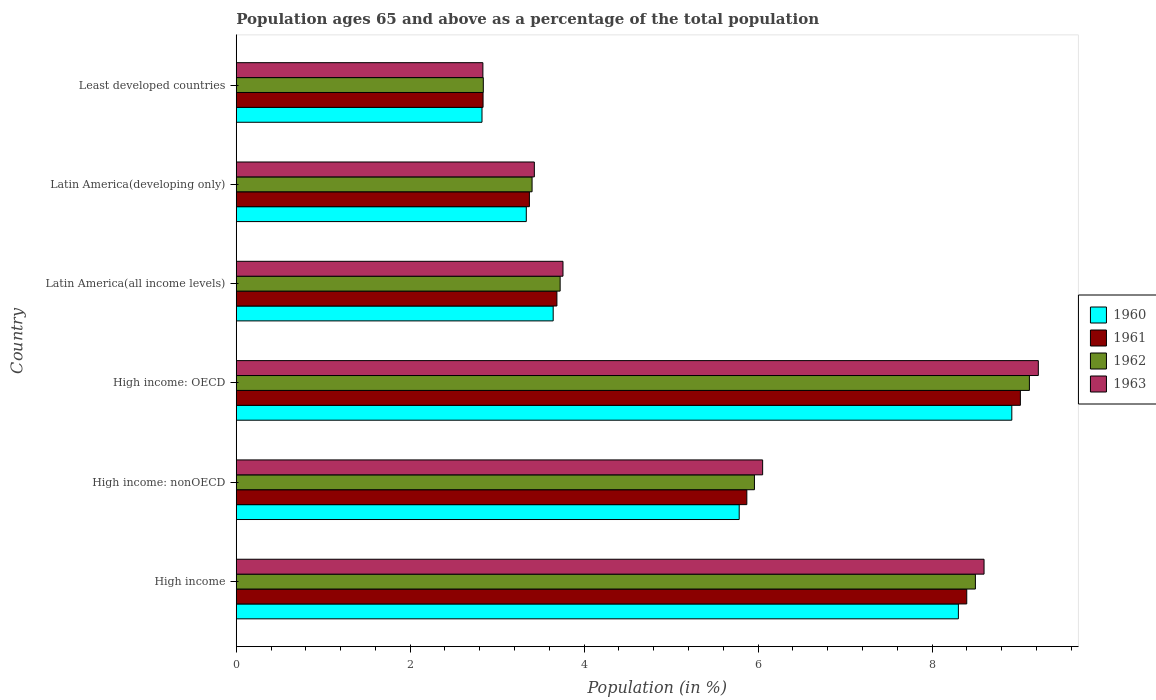How many groups of bars are there?
Provide a short and direct response. 6. Are the number of bars per tick equal to the number of legend labels?
Your answer should be very brief. Yes. Are the number of bars on each tick of the Y-axis equal?
Give a very brief answer. Yes. What is the label of the 1st group of bars from the top?
Keep it short and to the point. Least developed countries. What is the percentage of the population ages 65 and above in 1960 in Latin America(all income levels)?
Provide a succinct answer. 3.64. Across all countries, what is the maximum percentage of the population ages 65 and above in 1963?
Make the answer very short. 9.22. Across all countries, what is the minimum percentage of the population ages 65 and above in 1960?
Your answer should be very brief. 2.83. In which country was the percentage of the population ages 65 and above in 1960 maximum?
Your answer should be compact. High income: OECD. In which country was the percentage of the population ages 65 and above in 1963 minimum?
Give a very brief answer. Least developed countries. What is the total percentage of the population ages 65 and above in 1961 in the graph?
Your answer should be very brief. 33.18. What is the difference between the percentage of the population ages 65 and above in 1962 in High income and that in Least developed countries?
Provide a succinct answer. 5.66. What is the difference between the percentage of the population ages 65 and above in 1961 in Latin America(all income levels) and the percentage of the population ages 65 and above in 1960 in Latin America(developing only)?
Your answer should be very brief. 0.35. What is the average percentage of the population ages 65 and above in 1960 per country?
Give a very brief answer. 5.47. What is the difference between the percentage of the population ages 65 and above in 1963 and percentage of the population ages 65 and above in 1960 in High income?
Offer a terse response. 0.3. What is the ratio of the percentage of the population ages 65 and above in 1960 in High income: OECD to that in High income: nonOECD?
Your answer should be very brief. 1.54. Is the percentage of the population ages 65 and above in 1962 in High income less than that in Least developed countries?
Your response must be concise. No. What is the difference between the highest and the second highest percentage of the population ages 65 and above in 1963?
Your answer should be compact. 0.62. What is the difference between the highest and the lowest percentage of the population ages 65 and above in 1962?
Offer a very short reply. 6.28. In how many countries, is the percentage of the population ages 65 and above in 1963 greater than the average percentage of the population ages 65 and above in 1963 taken over all countries?
Offer a very short reply. 3. What does the 1st bar from the top in High income: nonOECD represents?
Keep it short and to the point. 1963. What does the 3rd bar from the bottom in High income: nonOECD represents?
Your answer should be very brief. 1962. How many bars are there?
Offer a terse response. 24. Are the values on the major ticks of X-axis written in scientific E-notation?
Offer a very short reply. No. Does the graph contain any zero values?
Keep it short and to the point. No. Does the graph contain grids?
Ensure brevity in your answer.  No. How many legend labels are there?
Give a very brief answer. 4. What is the title of the graph?
Provide a short and direct response. Population ages 65 and above as a percentage of the total population. What is the label or title of the Y-axis?
Make the answer very short. Country. What is the Population (in %) of 1960 in High income?
Make the answer very short. 8.3. What is the Population (in %) of 1961 in High income?
Ensure brevity in your answer.  8.4. What is the Population (in %) of 1962 in High income?
Provide a short and direct response. 8.5. What is the Population (in %) of 1963 in High income?
Your response must be concise. 8.6. What is the Population (in %) in 1960 in High income: nonOECD?
Your answer should be compact. 5.78. What is the Population (in %) of 1961 in High income: nonOECD?
Give a very brief answer. 5.87. What is the Population (in %) of 1962 in High income: nonOECD?
Offer a very short reply. 5.96. What is the Population (in %) of 1963 in High income: nonOECD?
Your answer should be compact. 6.05. What is the Population (in %) in 1960 in High income: OECD?
Your answer should be very brief. 8.92. What is the Population (in %) in 1961 in High income: OECD?
Your response must be concise. 9.02. What is the Population (in %) of 1962 in High income: OECD?
Ensure brevity in your answer.  9.12. What is the Population (in %) in 1963 in High income: OECD?
Provide a short and direct response. 9.22. What is the Population (in %) of 1960 in Latin America(all income levels)?
Provide a short and direct response. 3.64. What is the Population (in %) of 1961 in Latin America(all income levels)?
Your answer should be compact. 3.69. What is the Population (in %) of 1962 in Latin America(all income levels)?
Offer a very short reply. 3.72. What is the Population (in %) in 1963 in Latin America(all income levels)?
Provide a succinct answer. 3.76. What is the Population (in %) of 1960 in Latin America(developing only)?
Keep it short and to the point. 3.33. What is the Population (in %) in 1961 in Latin America(developing only)?
Provide a short and direct response. 3.37. What is the Population (in %) of 1962 in Latin America(developing only)?
Your answer should be very brief. 3.4. What is the Population (in %) in 1963 in Latin America(developing only)?
Ensure brevity in your answer.  3.43. What is the Population (in %) in 1960 in Least developed countries?
Your answer should be compact. 2.83. What is the Population (in %) in 1961 in Least developed countries?
Offer a very short reply. 2.84. What is the Population (in %) in 1962 in Least developed countries?
Ensure brevity in your answer.  2.84. What is the Population (in %) in 1963 in Least developed countries?
Your answer should be compact. 2.84. Across all countries, what is the maximum Population (in %) of 1960?
Ensure brevity in your answer.  8.92. Across all countries, what is the maximum Population (in %) in 1961?
Offer a very short reply. 9.02. Across all countries, what is the maximum Population (in %) of 1962?
Your answer should be very brief. 9.12. Across all countries, what is the maximum Population (in %) of 1963?
Your answer should be compact. 9.22. Across all countries, what is the minimum Population (in %) of 1960?
Give a very brief answer. 2.83. Across all countries, what is the minimum Population (in %) in 1961?
Ensure brevity in your answer.  2.84. Across all countries, what is the minimum Population (in %) in 1962?
Provide a succinct answer. 2.84. Across all countries, what is the minimum Population (in %) of 1963?
Ensure brevity in your answer.  2.84. What is the total Population (in %) in 1960 in the graph?
Your response must be concise. 32.81. What is the total Population (in %) of 1961 in the graph?
Ensure brevity in your answer.  33.18. What is the total Population (in %) in 1962 in the graph?
Ensure brevity in your answer.  33.54. What is the total Population (in %) of 1963 in the graph?
Provide a short and direct response. 33.89. What is the difference between the Population (in %) in 1960 in High income and that in High income: nonOECD?
Provide a short and direct response. 2.52. What is the difference between the Population (in %) in 1961 in High income and that in High income: nonOECD?
Give a very brief answer. 2.53. What is the difference between the Population (in %) in 1962 in High income and that in High income: nonOECD?
Ensure brevity in your answer.  2.54. What is the difference between the Population (in %) in 1963 in High income and that in High income: nonOECD?
Your answer should be compact. 2.55. What is the difference between the Population (in %) in 1960 in High income and that in High income: OECD?
Make the answer very short. -0.61. What is the difference between the Population (in %) in 1961 in High income and that in High income: OECD?
Offer a terse response. -0.62. What is the difference between the Population (in %) in 1962 in High income and that in High income: OECD?
Your answer should be very brief. -0.62. What is the difference between the Population (in %) in 1963 in High income and that in High income: OECD?
Offer a very short reply. -0.62. What is the difference between the Population (in %) in 1960 in High income and that in Latin America(all income levels)?
Provide a succinct answer. 4.66. What is the difference between the Population (in %) of 1961 in High income and that in Latin America(all income levels)?
Your answer should be very brief. 4.71. What is the difference between the Population (in %) of 1962 in High income and that in Latin America(all income levels)?
Your answer should be compact. 4.77. What is the difference between the Population (in %) of 1963 in High income and that in Latin America(all income levels)?
Your response must be concise. 4.84. What is the difference between the Population (in %) in 1960 in High income and that in Latin America(developing only)?
Your answer should be compact. 4.97. What is the difference between the Population (in %) in 1961 in High income and that in Latin America(developing only)?
Keep it short and to the point. 5.03. What is the difference between the Population (in %) of 1962 in High income and that in Latin America(developing only)?
Provide a succinct answer. 5.1. What is the difference between the Population (in %) in 1963 in High income and that in Latin America(developing only)?
Your answer should be very brief. 5.17. What is the difference between the Population (in %) of 1960 in High income and that in Least developed countries?
Give a very brief answer. 5.48. What is the difference between the Population (in %) of 1961 in High income and that in Least developed countries?
Offer a very short reply. 5.56. What is the difference between the Population (in %) of 1962 in High income and that in Least developed countries?
Offer a terse response. 5.66. What is the difference between the Population (in %) of 1963 in High income and that in Least developed countries?
Provide a succinct answer. 5.76. What is the difference between the Population (in %) of 1960 in High income: nonOECD and that in High income: OECD?
Provide a short and direct response. -3.13. What is the difference between the Population (in %) of 1961 in High income: nonOECD and that in High income: OECD?
Give a very brief answer. -3.15. What is the difference between the Population (in %) in 1962 in High income: nonOECD and that in High income: OECD?
Give a very brief answer. -3.16. What is the difference between the Population (in %) in 1963 in High income: nonOECD and that in High income: OECD?
Your answer should be very brief. -3.17. What is the difference between the Population (in %) in 1960 in High income: nonOECD and that in Latin America(all income levels)?
Give a very brief answer. 2.14. What is the difference between the Population (in %) in 1961 in High income: nonOECD and that in Latin America(all income levels)?
Your answer should be compact. 2.18. What is the difference between the Population (in %) in 1962 in High income: nonOECD and that in Latin America(all income levels)?
Give a very brief answer. 2.23. What is the difference between the Population (in %) in 1963 in High income: nonOECD and that in Latin America(all income levels)?
Offer a very short reply. 2.3. What is the difference between the Population (in %) of 1960 in High income: nonOECD and that in Latin America(developing only)?
Your response must be concise. 2.45. What is the difference between the Population (in %) in 1961 in High income: nonOECD and that in Latin America(developing only)?
Your answer should be very brief. 2.5. What is the difference between the Population (in %) in 1962 in High income: nonOECD and that in Latin America(developing only)?
Offer a terse response. 2.56. What is the difference between the Population (in %) in 1963 in High income: nonOECD and that in Latin America(developing only)?
Your answer should be very brief. 2.63. What is the difference between the Population (in %) of 1960 in High income: nonOECD and that in Least developed countries?
Your answer should be very brief. 2.96. What is the difference between the Population (in %) in 1961 in High income: nonOECD and that in Least developed countries?
Your answer should be compact. 3.03. What is the difference between the Population (in %) of 1962 in High income: nonOECD and that in Least developed countries?
Provide a succinct answer. 3.12. What is the difference between the Population (in %) of 1963 in High income: nonOECD and that in Least developed countries?
Make the answer very short. 3.22. What is the difference between the Population (in %) of 1960 in High income: OECD and that in Latin America(all income levels)?
Your response must be concise. 5.27. What is the difference between the Population (in %) of 1961 in High income: OECD and that in Latin America(all income levels)?
Keep it short and to the point. 5.33. What is the difference between the Population (in %) in 1962 in High income: OECD and that in Latin America(all income levels)?
Offer a terse response. 5.4. What is the difference between the Population (in %) of 1963 in High income: OECD and that in Latin America(all income levels)?
Your answer should be very brief. 5.47. What is the difference between the Population (in %) of 1960 in High income: OECD and that in Latin America(developing only)?
Offer a very short reply. 5.58. What is the difference between the Population (in %) of 1961 in High income: OECD and that in Latin America(developing only)?
Offer a very short reply. 5.65. What is the difference between the Population (in %) in 1962 in High income: OECD and that in Latin America(developing only)?
Offer a terse response. 5.72. What is the difference between the Population (in %) of 1963 in High income: OECD and that in Latin America(developing only)?
Your answer should be compact. 5.79. What is the difference between the Population (in %) in 1960 in High income: OECD and that in Least developed countries?
Provide a short and direct response. 6.09. What is the difference between the Population (in %) in 1961 in High income: OECD and that in Least developed countries?
Your answer should be compact. 6.18. What is the difference between the Population (in %) in 1962 in High income: OECD and that in Least developed countries?
Your answer should be very brief. 6.28. What is the difference between the Population (in %) in 1963 in High income: OECD and that in Least developed countries?
Give a very brief answer. 6.39. What is the difference between the Population (in %) of 1960 in Latin America(all income levels) and that in Latin America(developing only)?
Provide a short and direct response. 0.31. What is the difference between the Population (in %) of 1961 in Latin America(all income levels) and that in Latin America(developing only)?
Offer a very short reply. 0.32. What is the difference between the Population (in %) in 1962 in Latin America(all income levels) and that in Latin America(developing only)?
Give a very brief answer. 0.32. What is the difference between the Population (in %) of 1963 in Latin America(all income levels) and that in Latin America(developing only)?
Provide a succinct answer. 0.33. What is the difference between the Population (in %) in 1960 in Latin America(all income levels) and that in Least developed countries?
Provide a succinct answer. 0.82. What is the difference between the Population (in %) of 1961 in Latin America(all income levels) and that in Least developed countries?
Give a very brief answer. 0.85. What is the difference between the Population (in %) of 1962 in Latin America(all income levels) and that in Least developed countries?
Provide a succinct answer. 0.88. What is the difference between the Population (in %) of 1963 in Latin America(all income levels) and that in Least developed countries?
Provide a succinct answer. 0.92. What is the difference between the Population (in %) of 1960 in Latin America(developing only) and that in Least developed countries?
Provide a succinct answer. 0.51. What is the difference between the Population (in %) of 1961 in Latin America(developing only) and that in Least developed countries?
Offer a very short reply. 0.53. What is the difference between the Population (in %) of 1962 in Latin America(developing only) and that in Least developed countries?
Provide a succinct answer. 0.56. What is the difference between the Population (in %) in 1963 in Latin America(developing only) and that in Least developed countries?
Provide a short and direct response. 0.59. What is the difference between the Population (in %) in 1960 in High income and the Population (in %) in 1961 in High income: nonOECD?
Provide a succinct answer. 2.43. What is the difference between the Population (in %) of 1960 in High income and the Population (in %) of 1962 in High income: nonOECD?
Provide a succinct answer. 2.35. What is the difference between the Population (in %) of 1960 in High income and the Population (in %) of 1963 in High income: nonOECD?
Offer a very short reply. 2.25. What is the difference between the Population (in %) of 1961 in High income and the Population (in %) of 1962 in High income: nonOECD?
Your response must be concise. 2.44. What is the difference between the Population (in %) of 1961 in High income and the Population (in %) of 1963 in High income: nonOECD?
Offer a very short reply. 2.35. What is the difference between the Population (in %) in 1962 in High income and the Population (in %) in 1963 in High income: nonOECD?
Your answer should be very brief. 2.45. What is the difference between the Population (in %) of 1960 in High income and the Population (in %) of 1961 in High income: OECD?
Offer a terse response. -0.71. What is the difference between the Population (in %) in 1960 in High income and the Population (in %) in 1962 in High income: OECD?
Keep it short and to the point. -0.82. What is the difference between the Population (in %) of 1960 in High income and the Population (in %) of 1963 in High income: OECD?
Your response must be concise. -0.92. What is the difference between the Population (in %) in 1961 in High income and the Population (in %) in 1962 in High income: OECD?
Provide a short and direct response. -0.72. What is the difference between the Population (in %) in 1961 in High income and the Population (in %) in 1963 in High income: OECD?
Your response must be concise. -0.82. What is the difference between the Population (in %) of 1962 in High income and the Population (in %) of 1963 in High income: OECD?
Keep it short and to the point. -0.72. What is the difference between the Population (in %) of 1960 in High income and the Population (in %) of 1961 in Latin America(all income levels)?
Offer a very short reply. 4.62. What is the difference between the Population (in %) of 1960 in High income and the Population (in %) of 1962 in Latin America(all income levels)?
Provide a succinct answer. 4.58. What is the difference between the Population (in %) of 1960 in High income and the Population (in %) of 1963 in Latin America(all income levels)?
Provide a succinct answer. 4.55. What is the difference between the Population (in %) of 1961 in High income and the Population (in %) of 1962 in Latin America(all income levels)?
Provide a short and direct response. 4.68. What is the difference between the Population (in %) in 1961 in High income and the Population (in %) in 1963 in Latin America(all income levels)?
Your answer should be very brief. 4.64. What is the difference between the Population (in %) of 1962 in High income and the Population (in %) of 1963 in Latin America(all income levels)?
Your answer should be compact. 4.74. What is the difference between the Population (in %) of 1960 in High income and the Population (in %) of 1961 in Latin America(developing only)?
Make the answer very short. 4.93. What is the difference between the Population (in %) in 1960 in High income and the Population (in %) in 1962 in Latin America(developing only)?
Make the answer very short. 4.9. What is the difference between the Population (in %) in 1960 in High income and the Population (in %) in 1963 in Latin America(developing only)?
Give a very brief answer. 4.88. What is the difference between the Population (in %) in 1961 in High income and the Population (in %) in 1962 in Latin America(developing only)?
Offer a very short reply. 5. What is the difference between the Population (in %) of 1961 in High income and the Population (in %) of 1963 in Latin America(developing only)?
Provide a succinct answer. 4.97. What is the difference between the Population (in %) in 1962 in High income and the Population (in %) in 1963 in Latin America(developing only)?
Make the answer very short. 5.07. What is the difference between the Population (in %) in 1960 in High income and the Population (in %) in 1961 in Least developed countries?
Provide a succinct answer. 5.47. What is the difference between the Population (in %) of 1960 in High income and the Population (in %) of 1962 in Least developed countries?
Make the answer very short. 5.46. What is the difference between the Population (in %) in 1960 in High income and the Population (in %) in 1963 in Least developed countries?
Offer a terse response. 5.47. What is the difference between the Population (in %) in 1961 in High income and the Population (in %) in 1962 in Least developed countries?
Ensure brevity in your answer.  5.56. What is the difference between the Population (in %) of 1961 in High income and the Population (in %) of 1963 in Least developed countries?
Your answer should be very brief. 5.56. What is the difference between the Population (in %) in 1962 in High income and the Population (in %) in 1963 in Least developed countries?
Offer a very short reply. 5.66. What is the difference between the Population (in %) in 1960 in High income: nonOECD and the Population (in %) in 1961 in High income: OECD?
Give a very brief answer. -3.23. What is the difference between the Population (in %) of 1960 in High income: nonOECD and the Population (in %) of 1962 in High income: OECD?
Offer a terse response. -3.34. What is the difference between the Population (in %) of 1960 in High income: nonOECD and the Population (in %) of 1963 in High income: OECD?
Provide a succinct answer. -3.44. What is the difference between the Population (in %) in 1961 in High income: nonOECD and the Population (in %) in 1962 in High income: OECD?
Ensure brevity in your answer.  -3.25. What is the difference between the Population (in %) of 1961 in High income: nonOECD and the Population (in %) of 1963 in High income: OECD?
Your answer should be compact. -3.35. What is the difference between the Population (in %) in 1962 in High income: nonOECD and the Population (in %) in 1963 in High income: OECD?
Offer a terse response. -3.26. What is the difference between the Population (in %) in 1960 in High income: nonOECD and the Population (in %) in 1961 in Latin America(all income levels)?
Give a very brief answer. 2.1. What is the difference between the Population (in %) of 1960 in High income: nonOECD and the Population (in %) of 1962 in Latin America(all income levels)?
Offer a terse response. 2.06. What is the difference between the Population (in %) in 1960 in High income: nonOECD and the Population (in %) in 1963 in Latin America(all income levels)?
Your answer should be compact. 2.03. What is the difference between the Population (in %) of 1961 in High income: nonOECD and the Population (in %) of 1962 in Latin America(all income levels)?
Give a very brief answer. 2.15. What is the difference between the Population (in %) in 1961 in High income: nonOECD and the Population (in %) in 1963 in Latin America(all income levels)?
Ensure brevity in your answer.  2.11. What is the difference between the Population (in %) in 1962 in High income: nonOECD and the Population (in %) in 1963 in Latin America(all income levels)?
Offer a very short reply. 2.2. What is the difference between the Population (in %) in 1960 in High income: nonOECD and the Population (in %) in 1961 in Latin America(developing only)?
Give a very brief answer. 2.41. What is the difference between the Population (in %) in 1960 in High income: nonOECD and the Population (in %) in 1962 in Latin America(developing only)?
Provide a short and direct response. 2.38. What is the difference between the Population (in %) of 1960 in High income: nonOECD and the Population (in %) of 1963 in Latin America(developing only)?
Offer a very short reply. 2.36. What is the difference between the Population (in %) of 1961 in High income: nonOECD and the Population (in %) of 1962 in Latin America(developing only)?
Keep it short and to the point. 2.47. What is the difference between the Population (in %) of 1961 in High income: nonOECD and the Population (in %) of 1963 in Latin America(developing only)?
Offer a very short reply. 2.44. What is the difference between the Population (in %) of 1962 in High income: nonOECD and the Population (in %) of 1963 in Latin America(developing only)?
Offer a very short reply. 2.53. What is the difference between the Population (in %) of 1960 in High income: nonOECD and the Population (in %) of 1961 in Least developed countries?
Give a very brief answer. 2.95. What is the difference between the Population (in %) in 1960 in High income: nonOECD and the Population (in %) in 1962 in Least developed countries?
Ensure brevity in your answer.  2.94. What is the difference between the Population (in %) in 1960 in High income: nonOECD and the Population (in %) in 1963 in Least developed countries?
Offer a very short reply. 2.95. What is the difference between the Population (in %) in 1961 in High income: nonOECD and the Population (in %) in 1962 in Least developed countries?
Make the answer very short. 3.03. What is the difference between the Population (in %) of 1961 in High income: nonOECD and the Population (in %) of 1963 in Least developed countries?
Provide a short and direct response. 3.03. What is the difference between the Population (in %) in 1962 in High income: nonOECD and the Population (in %) in 1963 in Least developed countries?
Provide a short and direct response. 3.12. What is the difference between the Population (in %) in 1960 in High income: OECD and the Population (in %) in 1961 in Latin America(all income levels)?
Your answer should be compact. 5.23. What is the difference between the Population (in %) of 1960 in High income: OECD and the Population (in %) of 1962 in Latin America(all income levels)?
Give a very brief answer. 5.19. What is the difference between the Population (in %) of 1960 in High income: OECD and the Population (in %) of 1963 in Latin America(all income levels)?
Your answer should be compact. 5.16. What is the difference between the Population (in %) of 1961 in High income: OECD and the Population (in %) of 1962 in Latin America(all income levels)?
Make the answer very short. 5.29. What is the difference between the Population (in %) of 1961 in High income: OECD and the Population (in %) of 1963 in Latin America(all income levels)?
Your answer should be very brief. 5.26. What is the difference between the Population (in %) in 1962 in High income: OECD and the Population (in %) in 1963 in Latin America(all income levels)?
Your response must be concise. 5.36. What is the difference between the Population (in %) in 1960 in High income: OECD and the Population (in %) in 1961 in Latin America(developing only)?
Give a very brief answer. 5.55. What is the difference between the Population (in %) of 1960 in High income: OECD and the Population (in %) of 1962 in Latin America(developing only)?
Offer a very short reply. 5.52. What is the difference between the Population (in %) in 1960 in High income: OECD and the Population (in %) in 1963 in Latin America(developing only)?
Keep it short and to the point. 5.49. What is the difference between the Population (in %) of 1961 in High income: OECD and the Population (in %) of 1962 in Latin America(developing only)?
Offer a terse response. 5.61. What is the difference between the Population (in %) in 1961 in High income: OECD and the Population (in %) in 1963 in Latin America(developing only)?
Provide a succinct answer. 5.59. What is the difference between the Population (in %) in 1962 in High income: OECD and the Population (in %) in 1963 in Latin America(developing only)?
Your response must be concise. 5.69. What is the difference between the Population (in %) in 1960 in High income: OECD and the Population (in %) in 1961 in Least developed countries?
Your response must be concise. 6.08. What is the difference between the Population (in %) in 1960 in High income: OECD and the Population (in %) in 1962 in Least developed countries?
Provide a short and direct response. 6.08. What is the difference between the Population (in %) of 1960 in High income: OECD and the Population (in %) of 1963 in Least developed countries?
Keep it short and to the point. 6.08. What is the difference between the Population (in %) of 1961 in High income: OECD and the Population (in %) of 1962 in Least developed countries?
Your answer should be compact. 6.18. What is the difference between the Population (in %) in 1961 in High income: OECD and the Population (in %) in 1963 in Least developed countries?
Your answer should be very brief. 6.18. What is the difference between the Population (in %) in 1962 in High income: OECD and the Population (in %) in 1963 in Least developed countries?
Provide a succinct answer. 6.28. What is the difference between the Population (in %) of 1960 in Latin America(all income levels) and the Population (in %) of 1961 in Latin America(developing only)?
Offer a very short reply. 0.27. What is the difference between the Population (in %) in 1960 in Latin America(all income levels) and the Population (in %) in 1962 in Latin America(developing only)?
Offer a terse response. 0.24. What is the difference between the Population (in %) in 1960 in Latin America(all income levels) and the Population (in %) in 1963 in Latin America(developing only)?
Give a very brief answer. 0.22. What is the difference between the Population (in %) of 1961 in Latin America(all income levels) and the Population (in %) of 1962 in Latin America(developing only)?
Make the answer very short. 0.29. What is the difference between the Population (in %) in 1961 in Latin America(all income levels) and the Population (in %) in 1963 in Latin America(developing only)?
Your response must be concise. 0.26. What is the difference between the Population (in %) of 1962 in Latin America(all income levels) and the Population (in %) of 1963 in Latin America(developing only)?
Give a very brief answer. 0.3. What is the difference between the Population (in %) in 1960 in Latin America(all income levels) and the Population (in %) in 1961 in Least developed countries?
Your answer should be compact. 0.81. What is the difference between the Population (in %) of 1960 in Latin America(all income levels) and the Population (in %) of 1962 in Least developed countries?
Ensure brevity in your answer.  0.8. What is the difference between the Population (in %) of 1960 in Latin America(all income levels) and the Population (in %) of 1963 in Least developed countries?
Your answer should be compact. 0.81. What is the difference between the Population (in %) of 1961 in Latin America(all income levels) and the Population (in %) of 1962 in Least developed countries?
Make the answer very short. 0.85. What is the difference between the Population (in %) of 1961 in Latin America(all income levels) and the Population (in %) of 1963 in Least developed countries?
Ensure brevity in your answer.  0.85. What is the difference between the Population (in %) in 1962 in Latin America(all income levels) and the Population (in %) in 1963 in Least developed countries?
Provide a succinct answer. 0.89. What is the difference between the Population (in %) of 1960 in Latin America(developing only) and the Population (in %) of 1961 in Least developed countries?
Provide a short and direct response. 0.5. What is the difference between the Population (in %) in 1960 in Latin America(developing only) and the Population (in %) in 1962 in Least developed countries?
Your answer should be compact. 0.49. What is the difference between the Population (in %) in 1960 in Latin America(developing only) and the Population (in %) in 1963 in Least developed countries?
Give a very brief answer. 0.5. What is the difference between the Population (in %) of 1961 in Latin America(developing only) and the Population (in %) of 1962 in Least developed countries?
Make the answer very short. 0.53. What is the difference between the Population (in %) in 1961 in Latin America(developing only) and the Population (in %) in 1963 in Least developed countries?
Give a very brief answer. 0.53. What is the difference between the Population (in %) in 1962 in Latin America(developing only) and the Population (in %) in 1963 in Least developed countries?
Provide a succinct answer. 0.57. What is the average Population (in %) of 1960 per country?
Give a very brief answer. 5.47. What is the average Population (in %) in 1961 per country?
Give a very brief answer. 5.53. What is the average Population (in %) of 1962 per country?
Provide a short and direct response. 5.59. What is the average Population (in %) of 1963 per country?
Provide a succinct answer. 5.65. What is the difference between the Population (in %) of 1960 and Population (in %) of 1961 in High income?
Provide a short and direct response. -0.1. What is the difference between the Population (in %) of 1960 and Population (in %) of 1962 in High income?
Offer a very short reply. -0.2. What is the difference between the Population (in %) of 1960 and Population (in %) of 1963 in High income?
Provide a short and direct response. -0.3. What is the difference between the Population (in %) in 1961 and Population (in %) in 1962 in High income?
Your answer should be compact. -0.1. What is the difference between the Population (in %) of 1961 and Population (in %) of 1963 in High income?
Your response must be concise. -0.2. What is the difference between the Population (in %) of 1962 and Population (in %) of 1963 in High income?
Ensure brevity in your answer.  -0.1. What is the difference between the Population (in %) in 1960 and Population (in %) in 1961 in High income: nonOECD?
Offer a terse response. -0.09. What is the difference between the Population (in %) in 1960 and Population (in %) in 1962 in High income: nonOECD?
Ensure brevity in your answer.  -0.18. What is the difference between the Population (in %) of 1960 and Population (in %) of 1963 in High income: nonOECD?
Provide a short and direct response. -0.27. What is the difference between the Population (in %) in 1961 and Population (in %) in 1962 in High income: nonOECD?
Keep it short and to the point. -0.09. What is the difference between the Population (in %) of 1961 and Population (in %) of 1963 in High income: nonOECD?
Provide a short and direct response. -0.18. What is the difference between the Population (in %) in 1962 and Population (in %) in 1963 in High income: nonOECD?
Your response must be concise. -0.09. What is the difference between the Population (in %) in 1960 and Population (in %) in 1961 in High income: OECD?
Ensure brevity in your answer.  -0.1. What is the difference between the Population (in %) of 1960 and Population (in %) of 1962 in High income: OECD?
Provide a succinct answer. -0.2. What is the difference between the Population (in %) in 1960 and Population (in %) in 1963 in High income: OECD?
Offer a terse response. -0.3. What is the difference between the Population (in %) of 1961 and Population (in %) of 1962 in High income: OECD?
Your response must be concise. -0.1. What is the difference between the Population (in %) of 1961 and Population (in %) of 1963 in High income: OECD?
Keep it short and to the point. -0.21. What is the difference between the Population (in %) of 1962 and Population (in %) of 1963 in High income: OECD?
Your response must be concise. -0.1. What is the difference between the Population (in %) in 1960 and Population (in %) in 1961 in Latin America(all income levels)?
Your answer should be very brief. -0.04. What is the difference between the Population (in %) of 1960 and Population (in %) of 1962 in Latin America(all income levels)?
Offer a terse response. -0.08. What is the difference between the Population (in %) of 1960 and Population (in %) of 1963 in Latin America(all income levels)?
Give a very brief answer. -0.11. What is the difference between the Population (in %) in 1961 and Population (in %) in 1962 in Latin America(all income levels)?
Offer a terse response. -0.04. What is the difference between the Population (in %) in 1961 and Population (in %) in 1963 in Latin America(all income levels)?
Your answer should be compact. -0.07. What is the difference between the Population (in %) of 1962 and Population (in %) of 1963 in Latin America(all income levels)?
Make the answer very short. -0.03. What is the difference between the Population (in %) of 1960 and Population (in %) of 1961 in Latin America(developing only)?
Your response must be concise. -0.04. What is the difference between the Population (in %) of 1960 and Population (in %) of 1962 in Latin America(developing only)?
Offer a very short reply. -0.07. What is the difference between the Population (in %) of 1960 and Population (in %) of 1963 in Latin America(developing only)?
Offer a very short reply. -0.09. What is the difference between the Population (in %) in 1961 and Population (in %) in 1962 in Latin America(developing only)?
Give a very brief answer. -0.03. What is the difference between the Population (in %) in 1961 and Population (in %) in 1963 in Latin America(developing only)?
Ensure brevity in your answer.  -0.06. What is the difference between the Population (in %) of 1962 and Population (in %) of 1963 in Latin America(developing only)?
Make the answer very short. -0.03. What is the difference between the Population (in %) of 1960 and Population (in %) of 1961 in Least developed countries?
Offer a very short reply. -0.01. What is the difference between the Population (in %) of 1960 and Population (in %) of 1962 in Least developed countries?
Provide a short and direct response. -0.02. What is the difference between the Population (in %) in 1960 and Population (in %) in 1963 in Least developed countries?
Keep it short and to the point. -0.01. What is the difference between the Population (in %) in 1961 and Population (in %) in 1962 in Least developed countries?
Offer a very short reply. -0. What is the difference between the Population (in %) of 1961 and Population (in %) of 1963 in Least developed countries?
Provide a succinct answer. 0. What is the difference between the Population (in %) in 1962 and Population (in %) in 1963 in Least developed countries?
Provide a succinct answer. 0. What is the ratio of the Population (in %) in 1960 in High income to that in High income: nonOECD?
Keep it short and to the point. 1.44. What is the ratio of the Population (in %) in 1961 in High income to that in High income: nonOECD?
Your answer should be compact. 1.43. What is the ratio of the Population (in %) in 1962 in High income to that in High income: nonOECD?
Your answer should be very brief. 1.43. What is the ratio of the Population (in %) in 1963 in High income to that in High income: nonOECD?
Your response must be concise. 1.42. What is the ratio of the Population (in %) of 1960 in High income to that in High income: OECD?
Give a very brief answer. 0.93. What is the ratio of the Population (in %) in 1961 in High income to that in High income: OECD?
Your answer should be compact. 0.93. What is the ratio of the Population (in %) of 1962 in High income to that in High income: OECD?
Your answer should be compact. 0.93. What is the ratio of the Population (in %) in 1963 in High income to that in High income: OECD?
Ensure brevity in your answer.  0.93. What is the ratio of the Population (in %) of 1960 in High income to that in Latin America(all income levels)?
Provide a succinct answer. 2.28. What is the ratio of the Population (in %) of 1961 in High income to that in Latin America(all income levels)?
Offer a very short reply. 2.28. What is the ratio of the Population (in %) of 1962 in High income to that in Latin America(all income levels)?
Keep it short and to the point. 2.28. What is the ratio of the Population (in %) in 1963 in High income to that in Latin America(all income levels)?
Provide a succinct answer. 2.29. What is the ratio of the Population (in %) of 1960 in High income to that in Latin America(developing only)?
Your answer should be very brief. 2.49. What is the ratio of the Population (in %) of 1961 in High income to that in Latin America(developing only)?
Your answer should be compact. 2.49. What is the ratio of the Population (in %) in 1962 in High income to that in Latin America(developing only)?
Provide a succinct answer. 2.5. What is the ratio of the Population (in %) in 1963 in High income to that in Latin America(developing only)?
Your response must be concise. 2.51. What is the ratio of the Population (in %) in 1960 in High income to that in Least developed countries?
Your answer should be very brief. 2.94. What is the ratio of the Population (in %) of 1961 in High income to that in Least developed countries?
Keep it short and to the point. 2.96. What is the ratio of the Population (in %) in 1962 in High income to that in Least developed countries?
Your answer should be very brief. 2.99. What is the ratio of the Population (in %) in 1963 in High income to that in Least developed countries?
Your answer should be compact. 3.03. What is the ratio of the Population (in %) in 1960 in High income: nonOECD to that in High income: OECD?
Provide a succinct answer. 0.65. What is the ratio of the Population (in %) of 1961 in High income: nonOECD to that in High income: OECD?
Make the answer very short. 0.65. What is the ratio of the Population (in %) of 1962 in High income: nonOECD to that in High income: OECD?
Provide a succinct answer. 0.65. What is the ratio of the Population (in %) in 1963 in High income: nonOECD to that in High income: OECD?
Keep it short and to the point. 0.66. What is the ratio of the Population (in %) in 1960 in High income: nonOECD to that in Latin America(all income levels)?
Offer a terse response. 1.59. What is the ratio of the Population (in %) in 1961 in High income: nonOECD to that in Latin America(all income levels)?
Offer a very short reply. 1.59. What is the ratio of the Population (in %) in 1962 in High income: nonOECD to that in Latin America(all income levels)?
Provide a short and direct response. 1.6. What is the ratio of the Population (in %) in 1963 in High income: nonOECD to that in Latin America(all income levels)?
Keep it short and to the point. 1.61. What is the ratio of the Population (in %) in 1960 in High income: nonOECD to that in Latin America(developing only)?
Make the answer very short. 1.73. What is the ratio of the Population (in %) in 1961 in High income: nonOECD to that in Latin America(developing only)?
Your answer should be compact. 1.74. What is the ratio of the Population (in %) in 1962 in High income: nonOECD to that in Latin America(developing only)?
Ensure brevity in your answer.  1.75. What is the ratio of the Population (in %) in 1963 in High income: nonOECD to that in Latin America(developing only)?
Your answer should be very brief. 1.77. What is the ratio of the Population (in %) of 1960 in High income: nonOECD to that in Least developed countries?
Offer a terse response. 2.05. What is the ratio of the Population (in %) of 1961 in High income: nonOECD to that in Least developed countries?
Your answer should be very brief. 2.07. What is the ratio of the Population (in %) in 1962 in High income: nonOECD to that in Least developed countries?
Make the answer very short. 2.1. What is the ratio of the Population (in %) in 1963 in High income: nonOECD to that in Least developed countries?
Give a very brief answer. 2.13. What is the ratio of the Population (in %) in 1960 in High income: OECD to that in Latin America(all income levels)?
Provide a succinct answer. 2.45. What is the ratio of the Population (in %) of 1961 in High income: OECD to that in Latin America(all income levels)?
Make the answer very short. 2.45. What is the ratio of the Population (in %) in 1962 in High income: OECD to that in Latin America(all income levels)?
Your answer should be compact. 2.45. What is the ratio of the Population (in %) in 1963 in High income: OECD to that in Latin America(all income levels)?
Offer a terse response. 2.45. What is the ratio of the Population (in %) of 1960 in High income: OECD to that in Latin America(developing only)?
Offer a very short reply. 2.67. What is the ratio of the Population (in %) in 1961 in High income: OECD to that in Latin America(developing only)?
Make the answer very short. 2.67. What is the ratio of the Population (in %) in 1962 in High income: OECD to that in Latin America(developing only)?
Make the answer very short. 2.68. What is the ratio of the Population (in %) of 1963 in High income: OECD to that in Latin America(developing only)?
Offer a very short reply. 2.69. What is the ratio of the Population (in %) in 1960 in High income: OECD to that in Least developed countries?
Your answer should be compact. 3.16. What is the ratio of the Population (in %) of 1961 in High income: OECD to that in Least developed countries?
Your response must be concise. 3.18. What is the ratio of the Population (in %) of 1962 in High income: OECD to that in Least developed countries?
Provide a short and direct response. 3.21. What is the ratio of the Population (in %) in 1963 in High income: OECD to that in Least developed countries?
Offer a very short reply. 3.25. What is the ratio of the Population (in %) in 1960 in Latin America(all income levels) to that in Latin America(developing only)?
Your answer should be compact. 1.09. What is the ratio of the Population (in %) of 1961 in Latin America(all income levels) to that in Latin America(developing only)?
Keep it short and to the point. 1.09. What is the ratio of the Population (in %) of 1962 in Latin America(all income levels) to that in Latin America(developing only)?
Give a very brief answer. 1.09. What is the ratio of the Population (in %) in 1963 in Latin America(all income levels) to that in Latin America(developing only)?
Offer a terse response. 1.1. What is the ratio of the Population (in %) of 1960 in Latin America(all income levels) to that in Least developed countries?
Provide a succinct answer. 1.29. What is the ratio of the Population (in %) in 1961 in Latin America(all income levels) to that in Least developed countries?
Your answer should be very brief. 1.3. What is the ratio of the Population (in %) of 1962 in Latin America(all income levels) to that in Least developed countries?
Keep it short and to the point. 1.31. What is the ratio of the Population (in %) of 1963 in Latin America(all income levels) to that in Least developed countries?
Provide a short and direct response. 1.32. What is the ratio of the Population (in %) of 1960 in Latin America(developing only) to that in Least developed countries?
Provide a short and direct response. 1.18. What is the ratio of the Population (in %) in 1961 in Latin America(developing only) to that in Least developed countries?
Your answer should be compact. 1.19. What is the ratio of the Population (in %) of 1962 in Latin America(developing only) to that in Least developed countries?
Offer a very short reply. 1.2. What is the ratio of the Population (in %) in 1963 in Latin America(developing only) to that in Least developed countries?
Make the answer very short. 1.21. What is the difference between the highest and the second highest Population (in %) in 1960?
Keep it short and to the point. 0.61. What is the difference between the highest and the second highest Population (in %) in 1961?
Give a very brief answer. 0.62. What is the difference between the highest and the second highest Population (in %) of 1962?
Ensure brevity in your answer.  0.62. What is the difference between the highest and the second highest Population (in %) in 1963?
Keep it short and to the point. 0.62. What is the difference between the highest and the lowest Population (in %) in 1960?
Provide a short and direct response. 6.09. What is the difference between the highest and the lowest Population (in %) in 1961?
Your response must be concise. 6.18. What is the difference between the highest and the lowest Population (in %) in 1962?
Your response must be concise. 6.28. What is the difference between the highest and the lowest Population (in %) in 1963?
Offer a terse response. 6.39. 